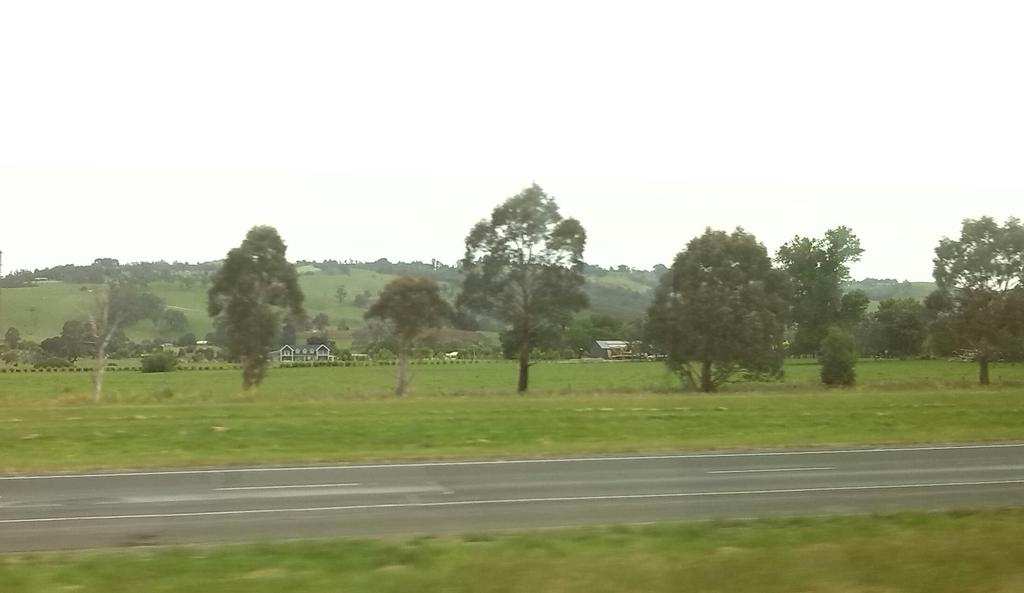What is located in the foreground of the image? There is a pathway in the foreground of the image. What can be seen in the center of the image? There is a group of trees and buildings in the center of the image. What is visible in the background of the image? There is a mountain and the sky visible in the background of the image. Can you tell me where the baseball game is taking place in the image? There is no baseball game present in the image. What type of discovery was made at the airport in the image? There is no airport or discovery present in the image. 